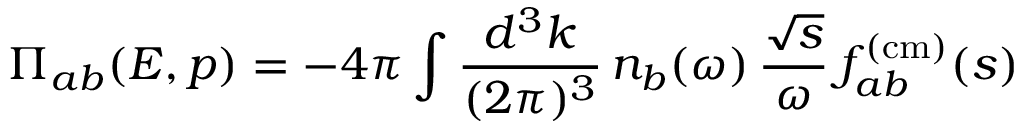Convert formula to latex. <formula><loc_0><loc_0><loc_500><loc_500>\Pi _ { a b } ( E , p ) = - 4 \pi \int \frac { d ^ { 3 } k } { ( 2 \pi ) ^ { 3 } } \, n _ { b } ( \omega ) \, \frac { \sqrt { s } } { \omega } \, f _ { a b } ^ { ( c m ) } ( s )</formula> 